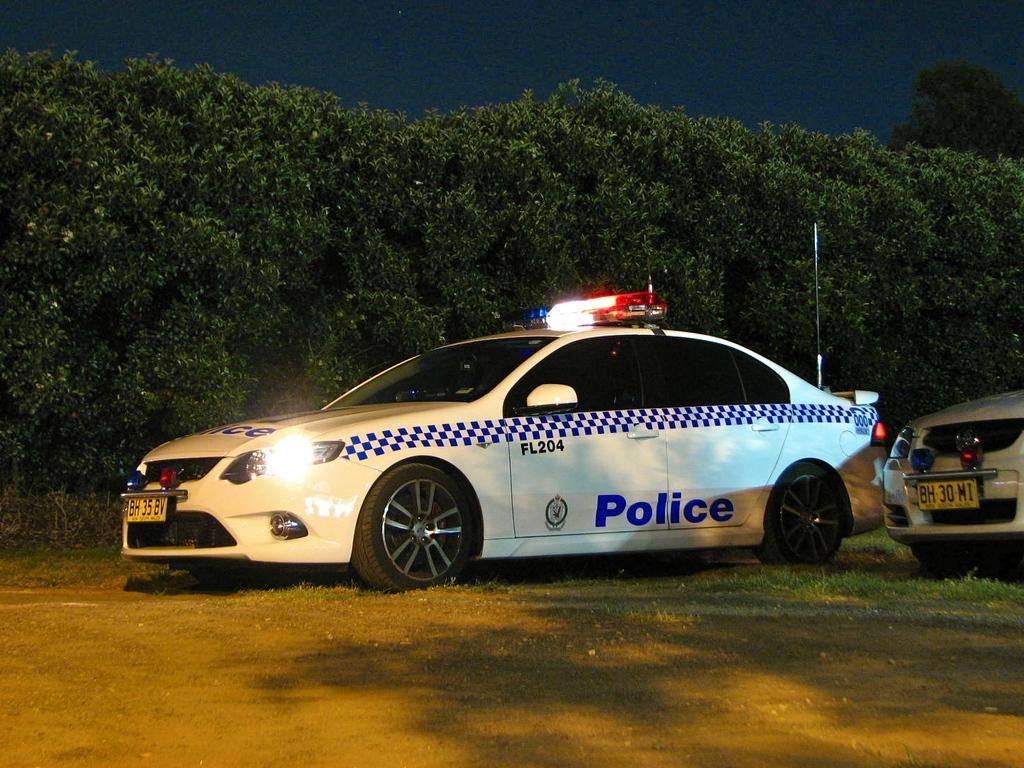What can be seen on the ground in the image? There are vehicles on the ground in the image. What type of natural elements are visible in the image? There are trees visible in the image. What is visible in the background of the image? The sky is visible in the background of the image. Where is the pot located in the image? There is no pot present in the image. What type of sheet is visible in the image? There is no sheet present in the image. 